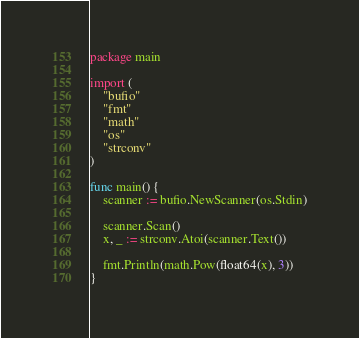Convert code to text. <code><loc_0><loc_0><loc_500><loc_500><_Go_>package main

import (
	"bufio"
	"fmt"
	"math"
	"os"
	"strconv"
)

func main() {
	scanner := bufio.NewScanner(os.Stdin)

	scanner.Scan()
	x, _ := strconv.Atoi(scanner.Text())

	fmt.Println(math.Pow(float64(x), 3))
}

</code> 